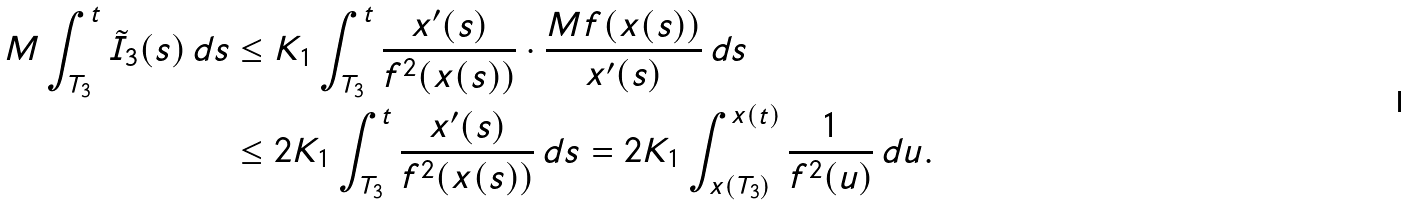<formula> <loc_0><loc_0><loc_500><loc_500>M \int _ { T _ { 3 } } ^ { t } \tilde { I } _ { 3 } ( s ) \, d s & \leq K _ { 1 } \int _ { T _ { 3 } } ^ { t } \frac { x ^ { \prime } ( s ) } { f ^ { 2 } ( x ( s ) ) } \cdot \frac { M f ( x ( s ) ) } { x ^ { \prime } ( s ) } \, d s \\ & \leq 2 K _ { 1 } \int _ { T _ { 3 } } ^ { t } \frac { x ^ { \prime } ( s ) } { f ^ { 2 } ( x ( s ) ) } \, d s = 2 K _ { 1 } \int _ { x ( T _ { 3 } ) } ^ { x ( t ) } \frac { 1 } { f ^ { 2 } ( u ) } \, d u .</formula> 